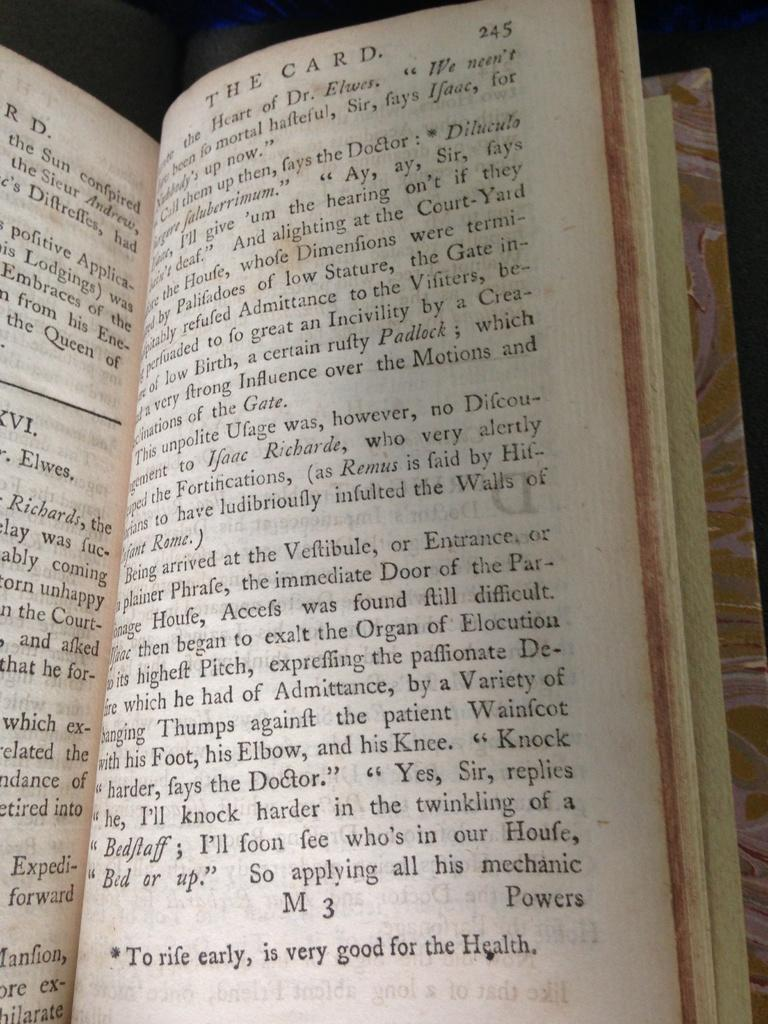<image>
Offer a succinct explanation of the picture presented. A book called The Card open to page 245. 